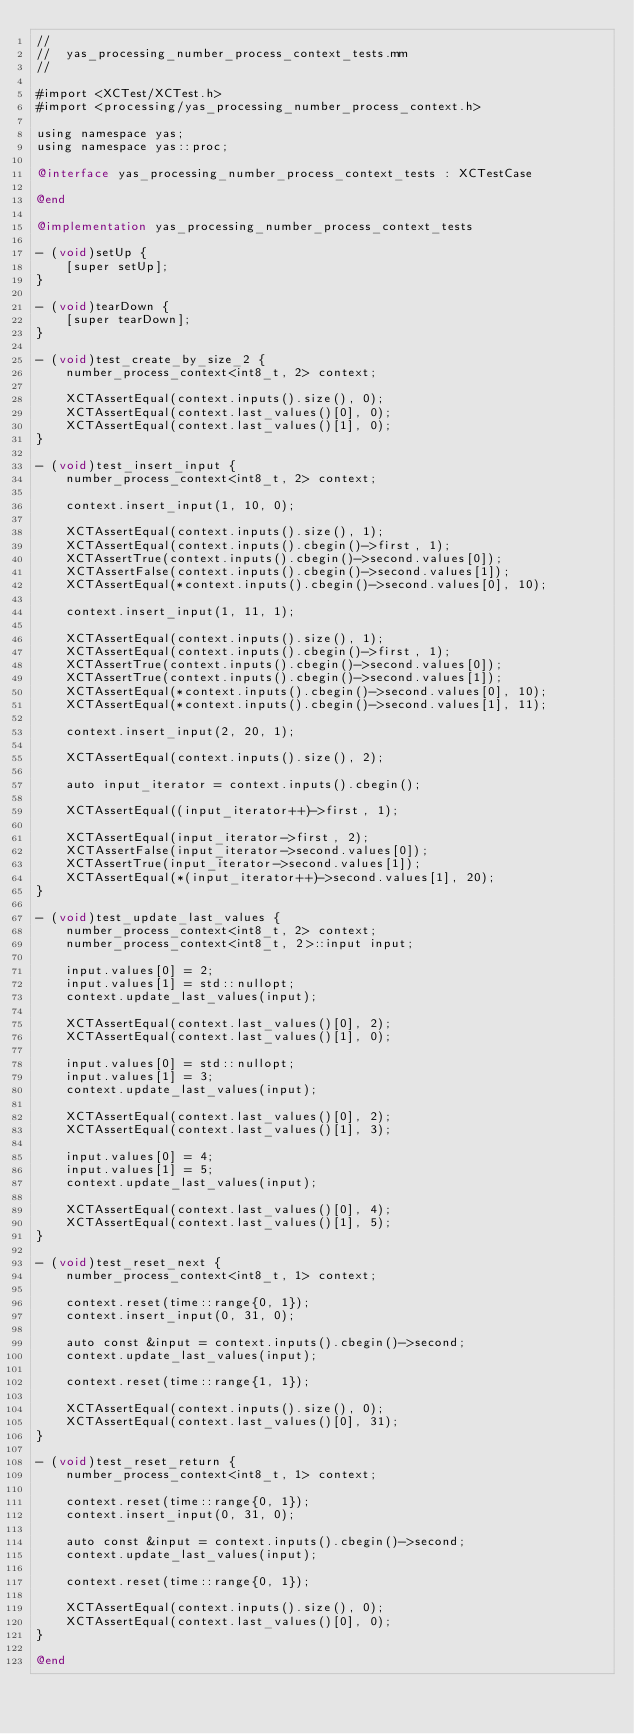<code> <loc_0><loc_0><loc_500><loc_500><_ObjectiveC_>//
//  yas_processing_number_process_context_tests.mm
//

#import <XCTest/XCTest.h>
#import <processing/yas_processing_number_process_context.h>

using namespace yas;
using namespace yas::proc;

@interface yas_processing_number_process_context_tests : XCTestCase

@end

@implementation yas_processing_number_process_context_tests

- (void)setUp {
    [super setUp];
}

- (void)tearDown {
    [super tearDown];
}

- (void)test_create_by_size_2 {
    number_process_context<int8_t, 2> context;

    XCTAssertEqual(context.inputs().size(), 0);
    XCTAssertEqual(context.last_values()[0], 0);
    XCTAssertEqual(context.last_values()[1], 0);
}

- (void)test_insert_input {
    number_process_context<int8_t, 2> context;

    context.insert_input(1, 10, 0);

    XCTAssertEqual(context.inputs().size(), 1);
    XCTAssertEqual(context.inputs().cbegin()->first, 1);
    XCTAssertTrue(context.inputs().cbegin()->second.values[0]);
    XCTAssertFalse(context.inputs().cbegin()->second.values[1]);
    XCTAssertEqual(*context.inputs().cbegin()->second.values[0], 10);

    context.insert_input(1, 11, 1);

    XCTAssertEqual(context.inputs().size(), 1);
    XCTAssertEqual(context.inputs().cbegin()->first, 1);
    XCTAssertTrue(context.inputs().cbegin()->second.values[0]);
    XCTAssertTrue(context.inputs().cbegin()->second.values[1]);
    XCTAssertEqual(*context.inputs().cbegin()->second.values[0], 10);
    XCTAssertEqual(*context.inputs().cbegin()->second.values[1], 11);

    context.insert_input(2, 20, 1);

    XCTAssertEqual(context.inputs().size(), 2);

    auto input_iterator = context.inputs().cbegin();

    XCTAssertEqual((input_iterator++)->first, 1);

    XCTAssertEqual(input_iterator->first, 2);
    XCTAssertFalse(input_iterator->second.values[0]);
    XCTAssertTrue(input_iterator->second.values[1]);
    XCTAssertEqual(*(input_iterator++)->second.values[1], 20);
}

- (void)test_update_last_values {
    number_process_context<int8_t, 2> context;
    number_process_context<int8_t, 2>::input input;

    input.values[0] = 2;
    input.values[1] = std::nullopt;
    context.update_last_values(input);

    XCTAssertEqual(context.last_values()[0], 2);
    XCTAssertEqual(context.last_values()[1], 0);

    input.values[0] = std::nullopt;
    input.values[1] = 3;
    context.update_last_values(input);

    XCTAssertEqual(context.last_values()[0], 2);
    XCTAssertEqual(context.last_values()[1], 3);

    input.values[0] = 4;
    input.values[1] = 5;
    context.update_last_values(input);

    XCTAssertEqual(context.last_values()[0], 4);
    XCTAssertEqual(context.last_values()[1], 5);
}

- (void)test_reset_next {
    number_process_context<int8_t, 1> context;

    context.reset(time::range{0, 1});
    context.insert_input(0, 31, 0);

    auto const &input = context.inputs().cbegin()->second;
    context.update_last_values(input);

    context.reset(time::range{1, 1});

    XCTAssertEqual(context.inputs().size(), 0);
    XCTAssertEqual(context.last_values()[0], 31);
}

- (void)test_reset_return {
    number_process_context<int8_t, 1> context;

    context.reset(time::range{0, 1});
    context.insert_input(0, 31, 0);

    auto const &input = context.inputs().cbegin()->second;
    context.update_last_values(input);

    context.reset(time::range{0, 1});

    XCTAssertEqual(context.inputs().size(), 0);
    XCTAssertEqual(context.last_values()[0], 0);
}

@end
</code> 